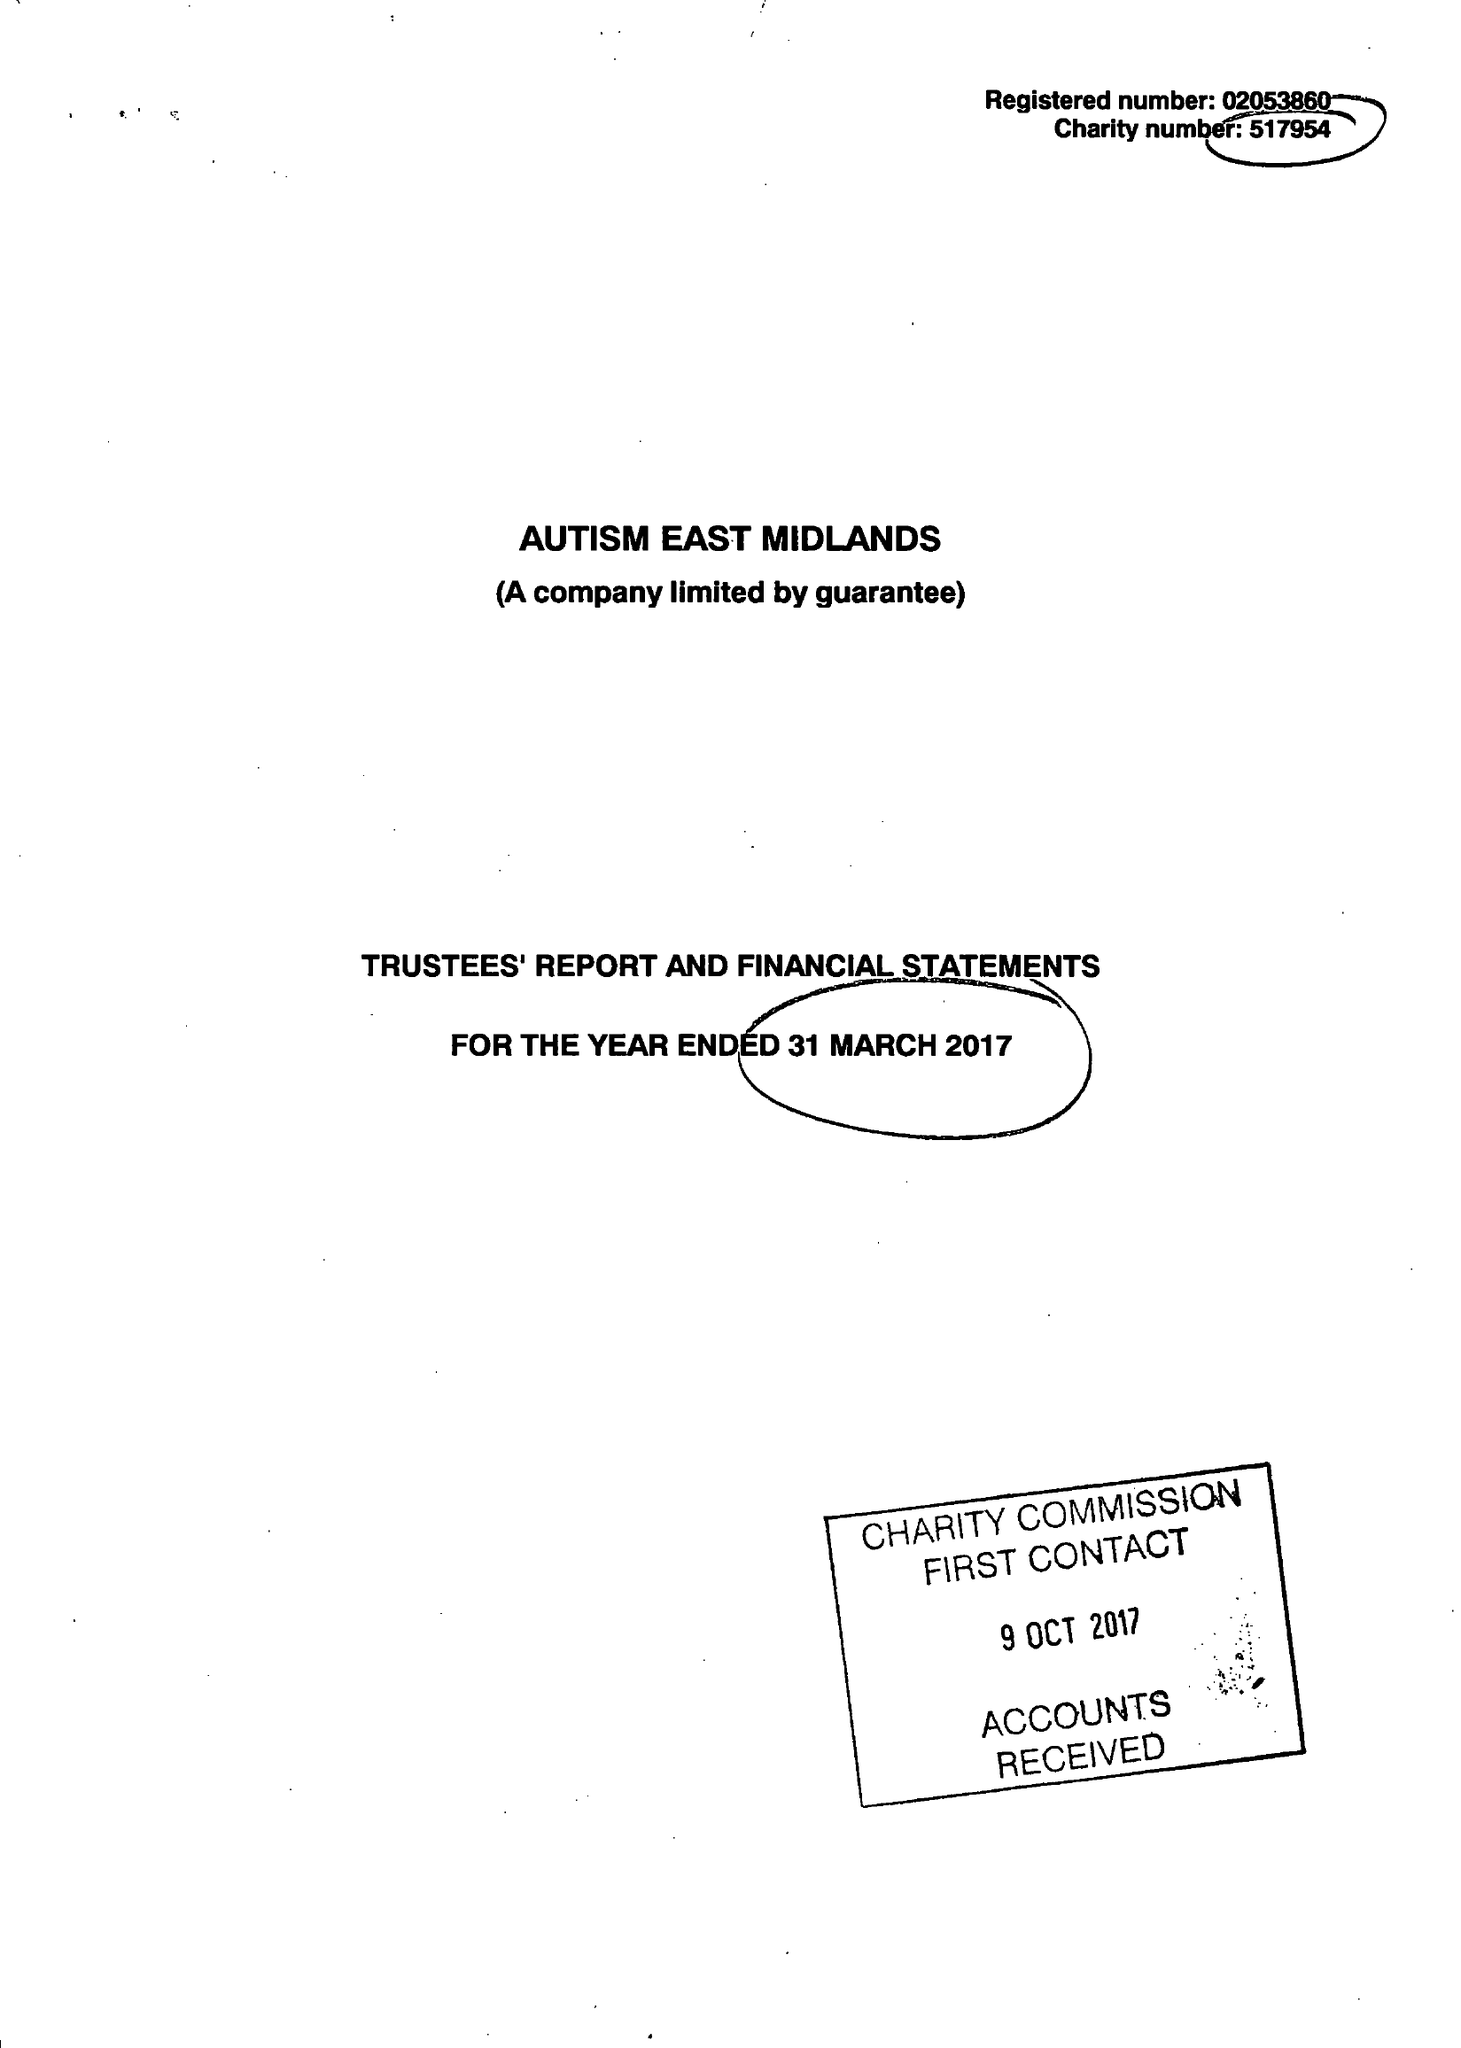What is the value for the spending_annually_in_british_pounds?
Answer the question using a single word or phrase. 11081470.00 